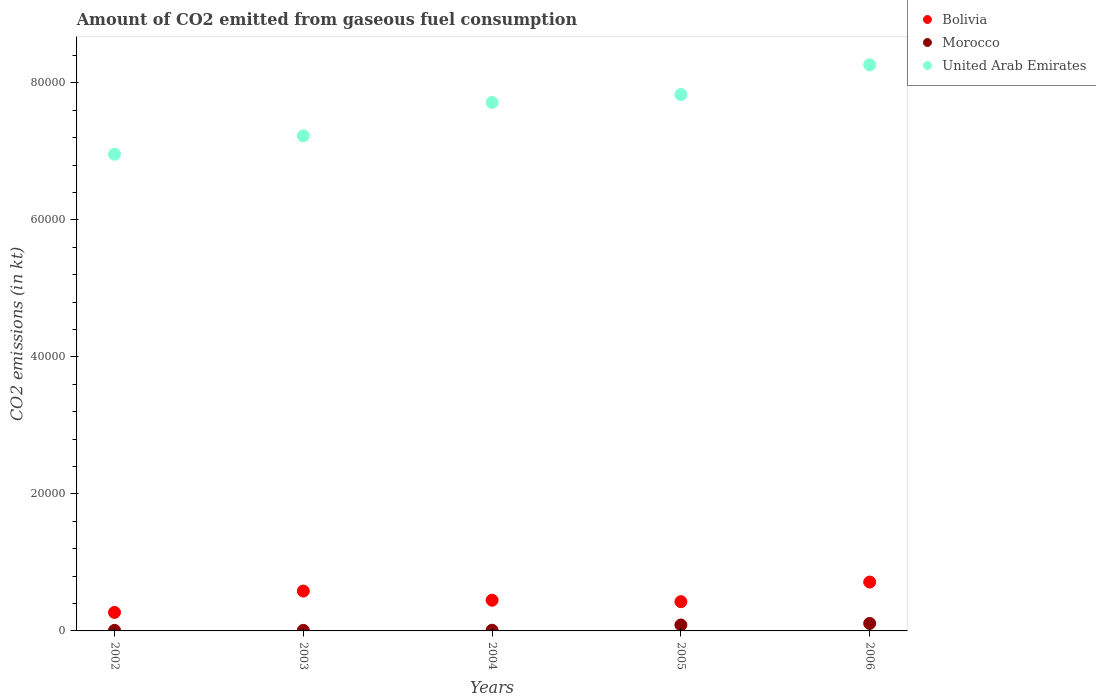How many different coloured dotlines are there?
Keep it short and to the point. 3. What is the amount of CO2 emitted in United Arab Emirates in 2004?
Give a very brief answer. 7.71e+04. Across all years, what is the maximum amount of CO2 emitted in United Arab Emirates?
Give a very brief answer. 8.26e+04. Across all years, what is the minimum amount of CO2 emitted in United Arab Emirates?
Ensure brevity in your answer.  6.96e+04. In which year was the amount of CO2 emitted in United Arab Emirates maximum?
Your answer should be very brief. 2006. What is the total amount of CO2 emitted in Morocco in the graph?
Make the answer very short. 2229.54. What is the difference between the amount of CO2 emitted in Bolivia in 2003 and that in 2005?
Ensure brevity in your answer.  1551.14. What is the difference between the amount of CO2 emitted in Bolivia in 2004 and the amount of CO2 emitted in United Arab Emirates in 2002?
Your answer should be compact. -6.51e+04. What is the average amount of CO2 emitted in Bolivia per year?
Your answer should be very brief. 4880.78. In the year 2004, what is the difference between the amount of CO2 emitted in United Arab Emirates and amount of CO2 emitted in Bolivia?
Offer a very short reply. 7.27e+04. What is the ratio of the amount of CO2 emitted in United Arab Emirates in 2004 to that in 2006?
Provide a succinct answer. 0.93. Is the amount of CO2 emitted in Morocco in 2003 less than that in 2004?
Ensure brevity in your answer.  Yes. Is the difference between the amount of CO2 emitted in United Arab Emirates in 2004 and 2005 greater than the difference between the amount of CO2 emitted in Bolivia in 2004 and 2005?
Your response must be concise. No. What is the difference between the highest and the second highest amount of CO2 emitted in Bolivia?
Keep it short and to the point. 1312.79. What is the difference between the highest and the lowest amount of CO2 emitted in Bolivia?
Provide a short and direct response. 4429.74. Is the sum of the amount of CO2 emitted in United Arab Emirates in 2003 and 2004 greater than the maximum amount of CO2 emitted in Bolivia across all years?
Offer a terse response. Yes. Is it the case that in every year, the sum of the amount of CO2 emitted in Morocco and amount of CO2 emitted in Bolivia  is greater than the amount of CO2 emitted in United Arab Emirates?
Your answer should be compact. No. Does the amount of CO2 emitted in Morocco monotonically increase over the years?
Ensure brevity in your answer.  No. Is the amount of CO2 emitted in Morocco strictly greater than the amount of CO2 emitted in Bolivia over the years?
Provide a succinct answer. No. How many dotlines are there?
Your response must be concise. 3. Does the graph contain grids?
Offer a terse response. No. How many legend labels are there?
Your response must be concise. 3. What is the title of the graph?
Provide a succinct answer. Amount of CO2 emitted from gaseous fuel consumption. What is the label or title of the X-axis?
Provide a short and direct response. Years. What is the label or title of the Y-axis?
Offer a terse response. CO2 emissions (in kt). What is the CO2 emissions (in kt) in Bolivia in 2002?
Provide a succinct answer. 2702.58. What is the CO2 emissions (in kt) in Morocco in 2002?
Give a very brief answer. 84.34. What is the CO2 emissions (in kt) in United Arab Emirates in 2002?
Make the answer very short. 6.96e+04. What is the CO2 emissions (in kt) of Bolivia in 2003?
Provide a short and direct response. 5819.53. What is the CO2 emissions (in kt) of Morocco in 2003?
Offer a very short reply. 80.67. What is the CO2 emissions (in kt) of United Arab Emirates in 2003?
Your answer should be compact. 7.23e+04. What is the CO2 emissions (in kt) of Bolivia in 2004?
Offer a very short reply. 4481.07. What is the CO2 emissions (in kt) in Morocco in 2004?
Give a very brief answer. 99.01. What is the CO2 emissions (in kt) of United Arab Emirates in 2004?
Give a very brief answer. 7.71e+04. What is the CO2 emissions (in kt) in Bolivia in 2005?
Offer a very short reply. 4268.39. What is the CO2 emissions (in kt) of Morocco in 2005?
Offer a very short reply. 869.08. What is the CO2 emissions (in kt) in United Arab Emirates in 2005?
Give a very brief answer. 7.83e+04. What is the CO2 emissions (in kt) in Bolivia in 2006?
Keep it short and to the point. 7132.31. What is the CO2 emissions (in kt) of Morocco in 2006?
Offer a very short reply. 1096.43. What is the CO2 emissions (in kt) in United Arab Emirates in 2006?
Keep it short and to the point. 8.26e+04. Across all years, what is the maximum CO2 emissions (in kt) of Bolivia?
Your answer should be very brief. 7132.31. Across all years, what is the maximum CO2 emissions (in kt) of Morocco?
Give a very brief answer. 1096.43. Across all years, what is the maximum CO2 emissions (in kt) in United Arab Emirates?
Your response must be concise. 8.26e+04. Across all years, what is the minimum CO2 emissions (in kt) in Bolivia?
Your response must be concise. 2702.58. Across all years, what is the minimum CO2 emissions (in kt) of Morocco?
Provide a short and direct response. 80.67. Across all years, what is the minimum CO2 emissions (in kt) in United Arab Emirates?
Make the answer very short. 6.96e+04. What is the total CO2 emissions (in kt) in Bolivia in the graph?
Offer a very short reply. 2.44e+04. What is the total CO2 emissions (in kt) in Morocco in the graph?
Keep it short and to the point. 2229.54. What is the total CO2 emissions (in kt) of United Arab Emirates in the graph?
Provide a short and direct response. 3.80e+05. What is the difference between the CO2 emissions (in kt) in Bolivia in 2002 and that in 2003?
Provide a succinct answer. -3116.95. What is the difference between the CO2 emissions (in kt) of Morocco in 2002 and that in 2003?
Provide a succinct answer. 3.67. What is the difference between the CO2 emissions (in kt) in United Arab Emirates in 2002 and that in 2003?
Make the answer very short. -2687.91. What is the difference between the CO2 emissions (in kt) in Bolivia in 2002 and that in 2004?
Provide a short and direct response. -1778.49. What is the difference between the CO2 emissions (in kt) in Morocco in 2002 and that in 2004?
Make the answer very short. -14.67. What is the difference between the CO2 emissions (in kt) in United Arab Emirates in 2002 and that in 2004?
Provide a succinct answer. -7554.02. What is the difference between the CO2 emissions (in kt) in Bolivia in 2002 and that in 2005?
Make the answer very short. -1565.81. What is the difference between the CO2 emissions (in kt) of Morocco in 2002 and that in 2005?
Provide a succinct answer. -784.74. What is the difference between the CO2 emissions (in kt) of United Arab Emirates in 2002 and that in 2005?
Offer a very short reply. -8705.46. What is the difference between the CO2 emissions (in kt) in Bolivia in 2002 and that in 2006?
Keep it short and to the point. -4429.74. What is the difference between the CO2 emissions (in kt) in Morocco in 2002 and that in 2006?
Provide a succinct answer. -1012.09. What is the difference between the CO2 emissions (in kt) in United Arab Emirates in 2002 and that in 2006?
Your response must be concise. -1.30e+04. What is the difference between the CO2 emissions (in kt) in Bolivia in 2003 and that in 2004?
Offer a very short reply. 1338.45. What is the difference between the CO2 emissions (in kt) of Morocco in 2003 and that in 2004?
Ensure brevity in your answer.  -18.34. What is the difference between the CO2 emissions (in kt) of United Arab Emirates in 2003 and that in 2004?
Keep it short and to the point. -4866.11. What is the difference between the CO2 emissions (in kt) in Bolivia in 2003 and that in 2005?
Offer a terse response. 1551.14. What is the difference between the CO2 emissions (in kt) in Morocco in 2003 and that in 2005?
Ensure brevity in your answer.  -788.4. What is the difference between the CO2 emissions (in kt) of United Arab Emirates in 2003 and that in 2005?
Your response must be concise. -6017.55. What is the difference between the CO2 emissions (in kt) in Bolivia in 2003 and that in 2006?
Offer a very short reply. -1312.79. What is the difference between the CO2 emissions (in kt) of Morocco in 2003 and that in 2006?
Your answer should be very brief. -1015.76. What is the difference between the CO2 emissions (in kt) in United Arab Emirates in 2003 and that in 2006?
Your answer should be compact. -1.04e+04. What is the difference between the CO2 emissions (in kt) in Bolivia in 2004 and that in 2005?
Your answer should be very brief. 212.69. What is the difference between the CO2 emissions (in kt) in Morocco in 2004 and that in 2005?
Your answer should be very brief. -770.07. What is the difference between the CO2 emissions (in kt) in United Arab Emirates in 2004 and that in 2005?
Your answer should be compact. -1151.44. What is the difference between the CO2 emissions (in kt) of Bolivia in 2004 and that in 2006?
Provide a short and direct response. -2651.24. What is the difference between the CO2 emissions (in kt) in Morocco in 2004 and that in 2006?
Your answer should be compact. -997.42. What is the difference between the CO2 emissions (in kt) of United Arab Emirates in 2004 and that in 2006?
Offer a terse response. -5489.5. What is the difference between the CO2 emissions (in kt) in Bolivia in 2005 and that in 2006?
Ensure brevity in your answer.  -2863.93. What is the difference between the CO2 emissions (in kt) in Morocco in 2005 and that in 2006?
Your answer should be compact. -227.35. What is the difference between the CO2 emissions (in kt) in United Arab Emirates in 2005 and that in 2006?
Make the answer very short. -4338.06. What is the difference between the CO2 emissions (in kt) in Bolivia in 2002 and the CO2 emissions (in kt) in Morocco in 2003?
Provide a short and direct response. 2621.91. What is the difference between the CO2 emissions (in kt) in Bolivia in 2002 and the CO2 emissions (in kt) in United Arab Emirates in 2003?
Give a very brief answer. -6.96e+04. What is the difference between the CO2 emissions (in kt) in Morocco in 2002 and the CO2 emissions (in kt) in United Arab Emirates in 2003?
Keep it short and to the point. -7.22e+04. What is the difference between the CO2 emissions (in kt) of Bolivia in 2002 and the CO2 emissions (in kt) of Morocco in 2004?
Give a very brief answer. 2603.57. What is the difference between the CO2 emissions (in kt) in Bolivia in 2002 and the CO2 emissions (in kt) in United Arab Emirates in 2004?
Ensure brevity in your answer.  -7.44e+04. What is the difference between the CO2 emissions (in kt) in Morocco in 2002 and the CO2 emissions (in kt) in United Arab Emirates in 2004?
Offer a very short reply. -7.71e+04. What is the difference between the CO2 emissions (in kt) in Bolivia in 2002 and the CO2 emissions (in kt) in Morocco in 2005?
Offer a terse response. 1833.5. What is the difference between the CO2 emissions (in kt) of Bolivia in 2002 and the CO2 emissions (in kt) of United Arab Emirates in 2005?
Your answer should be compact. -7.56e+04. What is the difference between the CO2 emissions (in kt) of Morocco in 2002 and the CO2 emissions (in kt) of United Arab Emirates in 2005?
Provide a short and direct response. -7.82e+04. What is the difference between the CO2 emissions (in kt) of Bolivia in 2002 and the CO2 emissions (in kt) of Morocco in 2006?
Offer a very short reply. 1606.15. What is the difference between the CO2 emissions (in kt) of Bolivia in 2002 and the CO2 emissions (in kt) of United Arab Emirates in 2006?
Offer a terse response. -7.99e+04. What is the difference between the CO2 emissions (in kt) in Morocco in 2002 and the CO2 emissions (in kt) in United Arab Emirates in 2006?
Keep it short and to the point. -8.25e+04. What is the difference between the CO2 emissions (in kt) of Bolivia in 2003 and the CO2 emissions (in kt) of Morocco in 2004?
Make the answer very short. 5720.52. What is the difference between the CO2 emissions (in kt) in Bolivia in 2003 and the CO2 emissions (in kt) in United Arab Emirates in 2004?
Provide a succinct answer. -7.13e+04. What is the difference between the CO2 emissions (in kt) of Morocco in 2003 and the CO2 emissions (in kt) of United Arab Emirates in 2004?
Provide a succinct answer. -7.71e+04. What is the difference between the CO2 emissions (in kt) in Bolivia in 2003 and the CO2 emissions (in kt) in Morocco in 2005?
Your answer should be compact. 4950.45. What is the difference between the CO2 emissions (in kt) in Bolivia in 2003 and the CO2 emissions (in kt) in United Arab Emirates in 2005?
Offer a very short reply. -7.25e+04. What is the difference between the CO2 emissions (in kt) of Morocco in 2003 and the CO2 emissions (in kt) of United Arab Emirates in 2005?
Keep it short and to the point. -7.82e+04. What is the difference between the CO2 emissions (in kt) of Bolivia in 2003 and the CO2 emissions (in kt) of Morocco in 2006?
Your answer should be compact. 4723.1. What is the difference between the CO2 emissions (in kt) in Bolivia in 2003 and the CO2 emissions (in kt) in United Arab Emirates in 2006?
Make the answer very short. -7.68e+04. What is the difference between the CO2 emissions (in kt) of Morocco in 2003 and the CO2 emissions (in kt) of United Arab Emirates in 2006?
Your answer should be very brief. -8.25e+04. What is the difference between the CO2 emissions (in kt) in Bolivia in 2004 and the CO2 emissions (in kt) in Morocco in 2005?
Make the answer very short. 3611.99. What is the difference between the CO2 emissions (in kt) in Bolivia in 2004 and the CO2 emissions (in kt) in United Arab Emirates in 2005?
Provide a succinct answer. -7.38e+04. What is the difference between the CO2 emissions (in kt) in Morocco in 2004 and the CO2 emissions (in kt) in United Arab Emirates in 2005?
Provide a succinct answer. -7.82e+04. What is the difference between the CO2 emissions (in kt) of Bolivia in 2004 and the CO2 emissions (in kt) of Morocco in 2006?
Give a very brief answer. 3384.64. What is the difference between the CO2 emissions (in kt) of Bolivia in 2004 and the CO2 emissions (in kt) of United Arab Emirates in 2006?
Make the answer very short. -7.81e+04. What is the difference between the CO2 emissions (in kt) in Morocco in 2004 and the CO2 emissions (in kt) in United Arab Emirates in 2006?
Keep it short and to the point. -8.25e+04. What is the difference between the CO2 emissions (in kt) in Bolivia in 2005 and the CO2 emissions (in kt) in Morocco in 2006?
Offer a terse response. 3171.95. What is the difference between the CO2 emissions (in kt) in Bolivia in 2005 and the CO2 emissions (in kt) in United Arab Emirates in 2006?
Your answer should be very brief. -7.84e+04. What is the difference between the CO2 emissions (in kt) of Morocco in 2005 and the CO2 emissions (in kt) of United Arab Emirates in 2006?
Your response must be concise. -8.18e+04. What is the average CO2 emissions (in kt) in Bolivia per year?
Offer a very short reply. 4880.78. What is the average CO2 emissions (in kt) in Morocco per year?
Ensure brevity in your answer.  445.91. What is the average CO2 emissions (in kt) in United Arab Emirates per year?
Keep it short and to the point. 7.60e+04. In the year 2002, what is the difference between the CO2 emissions (in kt) of Bolivia and CO2 emissions (in kt) of Morocco?
Your answer should be very brief. 2618.24. In the year 2002, what is the difference between the CO2 emissions (in kt) of Bolivia and CO2 emissions (in kt) of United Arab Emirates?
Keep it short and to the point. -6.69e+04. In the year 2002, what is the difference between the CO2 emissions (in kt) of Morocco and CO2 emissions (in kt) of United Arab Emirates?
Ensure brevity in your answer.  -6.95e+04. In the year 2003, what is the difference between the CO2 emissions (in kt) in Bolivia and CO2 emissions (in kt) in Morocco?
Give a very brief answer. 5738.85. In the year 2003, what is the difference between the CO2 emissions (in kt) in Bolivia and CO2 emissions (in kt) in United Arab Emirates?
Your answer should be very brief. -6.65e+04. In the year 2003, what is the difference between the CO2 emissions (in kt) in Morocco and CO2 emissions (in kt) in United Arab Emirates?
Provide a short and direct response. -7.22e+04. In the year 2004, what is the difference between the CO2 emissions (in kt) in Bolivia and CO2 emissions (in kt) in Morocco?
Offer a terse response. 4382.06. In the year 2004, what is the difference between the CO2 emissions (in kt) in Bolivia and CO2 emissions (in kt) in United Arab Emirates?
Provide a succinct answer. -7.27e+04. In the year 2004, what is the difference between the CO2 emissions (in kt) in Morocco and CO2 emissions (in kt) in United Arab Emirates?
Keep it short and to the point. -7.70e+04. In the year 2005, what is the difference between the CO2 emissions (in kt) of Bolivia and CO2 emissions (in kt) of Morocco?
Your answer should be compact. 3399.31. In the year 2005, what is the difference between the CO2 emissions (in kt) of Bolivia and CO2 emissions (in kt) of United Arab Emirates?
Provide a short and direct response. -7.40e+04. In the year 2005, what is the difference between the CO2 emissions (in kt) in Morocco and CO2 emissions (in kt) in United Arab Emirates?
Give a very brief answer. -7.74e+04. In the year 2006, what is the difference between the CO2 emissions (in kt) of Bolivia and CO2 emissions (in kt) of Morocco?
Keep it short and to the point. 6035.88. In the year 2006, what is the difference between the CO2 emissions (in kt) of Bolivia and CO2 emissions (in kt) of United Arab Emirates?
Make the answer very short. -7.55e+04. In the year 2006, what is the difference between the CO2 emissions (in kt) in Morocco and CO2 emissions (in kt) in United Arab Emirates?
Offer a very short reply. -8.15e+04. What is the ratio of the CO2 emissions (in kt) in Bolivia in 2002 to that in 2003?
Make the answer very short. 0.46. What is the ratio of the CO2 emissions (in kt) of Morocco in 2002 to that in 2003?
Offer a very short reply. 1.05. What is the ratio of the CO2 emissions (in kt) in United Arab Emirates in 2002 to that in 2003?
Your answer should be compact. 0.96. What is the ratio of the CO2 emissions (in kt) of Bolivia in 2002 to that in 2004?
Ensure brevity in your answer.  0.6. What is the ratio of the CO2 emissions (in kt) in Morocco in 2002 to that in 2004?
Your answer should be compact. 0.85. What is the ratio of the CO2 emissions (in kt) in United Arab Emirates in 2002 to that in 2004?
Offer a terse response. 0.9. What is the ratio of the CO2 emissions (in kt) of Bolivia in 2002 to that in 2005?
Your answer should be very brief. 0.63. What is the ratio of the CO2 emissions (in kt) of Morocco in 2002 to that in 2005?
Give a very brief answer. 0.1. What is the ratio of the CO2 emissions (in kt) in United Arab Emirates in 2002 to that in 2005?
Offer a terse response. 0.89. What is the ratio of the CO2 emissions (in kt) of Bolivia in 2002 to that in 2006?
Provide a succinct answer. 0.38. What is the ratio of the CO2 emissions (in kt) in Morocco in 2002 to that in 2006?
Offer a terse response. 0.08. What is the ratio of the CO2 emissions (in kt) of United Arab Emirates in 2002 to that in 2006?
Provide a short and direct response. 0.84. What is the ratio of the CO2 emissions (in kt) of Bolivia in 2003 to that in 2004?
Give a very brief answer. 1.3. What is the ratio of the CO2 emissions (in kt) in Morocco in 2003 to that in 2004?
Offer a very short reply. 0.81. What is the ratio of the CO2 emissions (in kt) of United Arab Emirates in 2003 to that in 2004?
Give a very brief answer. 0.94. What is the ratio of the CO2 emissions (in kt) of Bolivia in 2003 to that in 2005?
Your answer should be compact. 1.36. What is the ratio of the CO2 emissions (in kt) of Morocco in 2003 to that in 2005?
Your answer should be very brief. 0.09. What is the ratio of the CO2 emissions (in kt) in United Arab Emirates in 2003 to that in 2005?
Keep it short and to the point. 0.92. What is the ratio of the CO2 emissions (in kt) in Bolivia in 2003 to that in 2006?
Provide a succinct answer. 0.82. What is the ratio of the CO2 emissions (in kt) of Morocco in 2003 to that in 2006?
Offer a very short reply. 0.07. What is the ratio of the CO2 emissions (in kt) in United Arab Emirates in 2003 to that in 2006?
Make the answer very short. 0.87. What is the ratio of the CO2 emissions (in kt) of Bolivia in 2004 to that in 2005?
Your response must be concise. 1.05. What is the ratio of the CO2 emissions (in kt) in Morocco in 2004 to that in 2005?
Provide a succinct answer. 0.11. What is the ratio of the CO2 emissions (in kt) in United Arab Emirates in 2004 to that in 2005?
Offer a terse response. 0.99. What is the ratio of the CO2 emissions (in kt) of Bolivia in 2004 to that in 2006?
Provide a short and direct response. 0.63. What is the ratio of the CO2 emissions (in kt) of Morocco in 2004 to that in 2006?
Provide a short and direct response. 0.09. What is the ratio of the CO2 emissions (in kt) of United Arab Emirates in 2004 to that in 2006?
Ensure brevity in your answer.  0.93. What is the ratio of the CO2 emissions (in kt) in Bolivia in 2005 to that in 2006?
Provide a short and direct response. 0.6. What is the ratio of the CO2 emissions (in kt) of Morocco in 2005 to that in 2006?
Provide a succinct answer. 0.79. What is the ratio of the CO2 emissions (in kt) of United Arab Emirates in 2005 to that in 2006?
Make the answer very short. 0.95. What is the difference between the highest and the second highest CO2 emissions (in kt) of Bolivia?
Your answer should be very brief. 1312.79. What is the difference between the highest and the second highest CO2 emissions (in kt) in Morocco?
Keep it short and to the point. 227.35. What is the difference between the highest and the second highest CO2 emissions (in kt) in United Arab Emirates?
Offer a very short reply. 4338.06. What is the difference between the highest and the lowest CO2 emissions (in kt) of Bolivia?
Provide a succinct answer. 4429.74. What is the difference between the highest and the lowest CO2 emissions (in kt) in Morocco?
Keep it short and to the point. 1015.76. What is the difference between the highest and the lowest CO2 emissions (in kt) in United Arab Emirates?
Provide a succinct answer. 1.30e+04. 